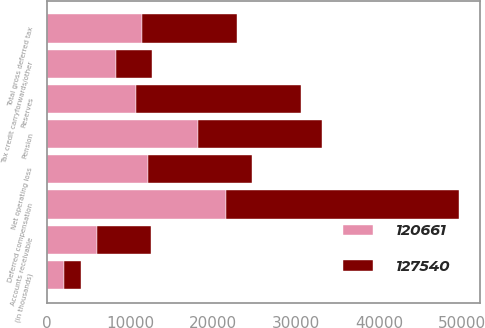Convert chart. <chart><loc_0><loc_0><loc_500><loc_500><stacked_bar_chart><ecel><fcel>(in thousands)<fcel>Accounts receivable<fcel>Deferred compensation<fcel>Pension<fcel>Reserves<fcel>Tax credit carryforwards/other<fcel>Net operating loss<fcel>Total gross deferred tax<nl><fcel>127540<fcel>2007<fcel>6551<fcel>28136<fcel>14979<fcel>19797<fcel>4321<fcel>12533<fcel>11430.5<nl><fcel>120661<fcel>2006<fcel>5963<fcel>21490<fcel>18168<fcel>10736<fcel>8344<fcel>12125<fcel>11430.5<nl></chart> 